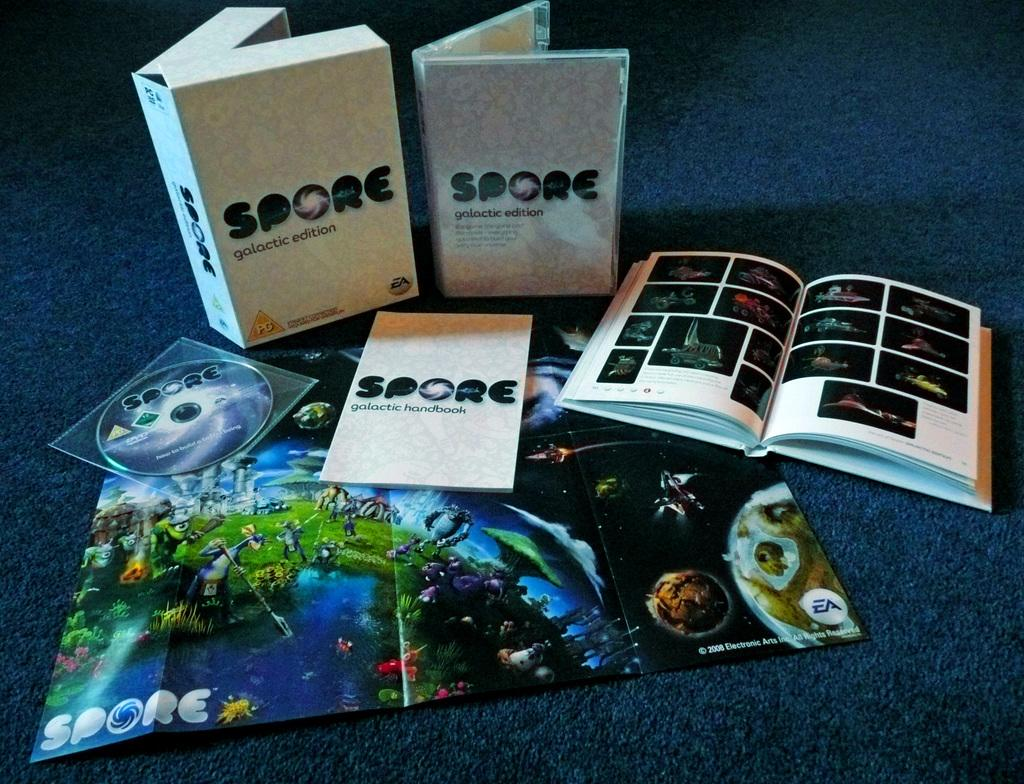Provide a one-sentence caption for the provided image. a box that says 'spore galactic edition' on it. 